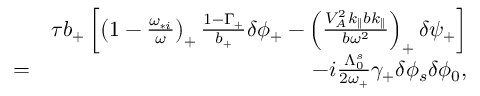Convert formula to latex. <formula><loc_0><loc_0><loc_500><loc_500>\begin{array} { r l r } & { \tau b _ { + } \left [ \left ( 1 - \frac { \omega _ { * i } } { \omega } \right ) _ { + } \frac { 1 - \Gamma _ { + } } { b _ { + } } \delta \phi _ { + } - \left ( \frac { V _ { A } ^ { 2 } k _ { \| } b k _ { \| } } { b \omega ^ { 2 } } \right ) _ { + } \delta \psi _ { + } \right ] } \\ & { = } & { - i \frac { \Lambda _ { 0 } ^ { s } } { 2 \omega _ { + } } \gamma _ { + } \delta \phi _ { s } \delta \phi _ { 0 } , } \end{array}</formula> 